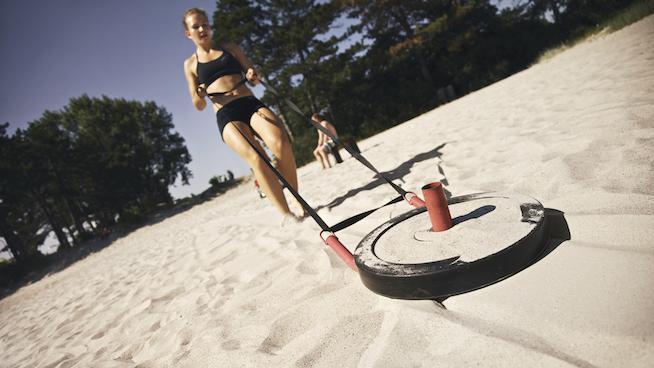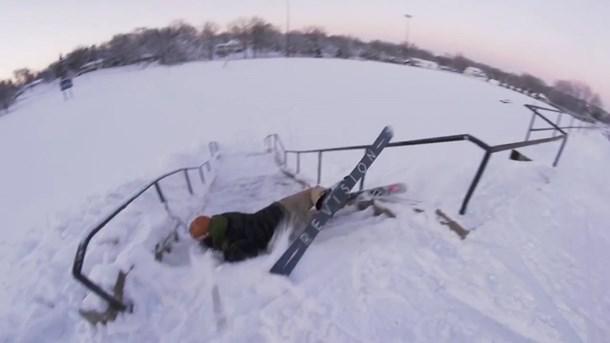The first image is the image on the left, the second image is the image on the right. Assess this claim about the two images: "At least one image shows a sled dog team headed straight, away from the camera.". Correct or not? Answer yes or no. No. 